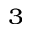Convert formula to latex. <formula><loc_0><loc_0><loc_500><loc_500>^ { 3 }</formula> 